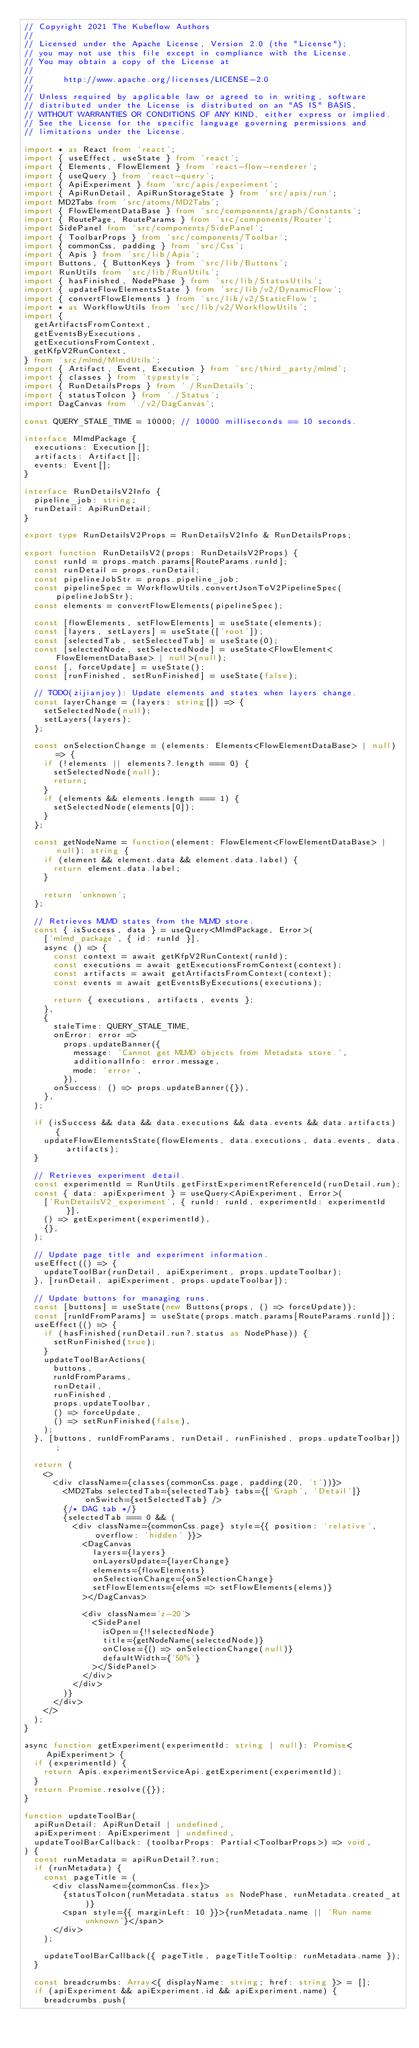Convert code to text. <code><loc_0><loc_0><loc_500><loc_500><_TypeScript_>// Copyright 2021 The Kubeflow Authors
//
// Licensed under the Apache License, Version 2.0 (the "License");
// you may not use this file except in compliance with the License.
// You may obtain a copy of the License at
//
//      http://www.apache.org/licenses/LICENSE-2.0
//
// Unless required by applicable law or agreed to in writing, software
// distributed under the License is distributed on an "AS IS" BASIS,
// WITHOUT WARRANTIES OR CONDITIONS OF ANY KIND, either express or implied.
// See the License for the specific language governing permissions and
// limitations under the License.

import * as React from 'react';
import { useEffect, useState } from 'react';
import { Elements, FlowElement } from 'react-flow-renderer';
import { useQuery } from 'react-query';
import { ApiExperiment } from 'src/apis/experiment';
import { ApiRunDetail, ApiRunStorageState } from 'src/apis/run';
import MD2Tabs from 'src/atoms/MD2Tabs';
import { FlowElementDataBase } from 'src/components/graph/Constants';
import { RoutePage, RouteParams } from 'src/components/Router';
import SidePanel from 'src/components/SidePanel';
import { ToolbarProps } from 'src/components/Toolbar';
import { commonCss, padding } from 'src/Css';
import { Apis } from 'src/lib/Apis';
import Buttons, { ButtonKeys } from 'src/lib/Buttons';
import RunUtils from 'src/lib/RunUtils';
import { hasFinished, NodePhase } from 'src/lib/StatusUtils';
import { updateFlowElementsState } from 'src/lib/v2/DynamicFlow';
import { convertFlowElements } from 'src/lib/v2/StaticFlow';
import * as WorkflowUtils from 'src/lib/v2/WorkflowUtils';
import {
  getArtifactsFromContext,
  getEventsByExecutions,
  getExecutionsFromContext,
  getKfpV2RunContext,
} from 'src/mlmd/MlmdUtils';
import { Artifact, Event, Execution } from 'src/third_party/mlmd';
import { classes } from 'typestyle';
import { RunDetailsProps } from './RunDetails';
import { statusToIcon } from './Status';
import DagCanvas from './v2/DagCanvas';

const QUERY_STALE_TIME = 10000; // 10000 milliseconds == 10 seconds.

interface MlmdPackage {
  executions: Execution[];
  artifacts: Artifact[];
  events: Event[];
}

interface RunDetailsV2Info {
  pipeline_job: string;
  runDetail: ApiRunDetail;
}

export type RunDetailsV2Props = RunDetailsV2Info & RunDetailsProps;

export function RunDetailsV2(props: RunDetailsV2Props) {
  const runId = props.match.params[RouteParams.runId];
  const runDetail = props.runDetail;
  const pipelineJobStr = props.pipeline_job;
  const pipelineSpec = WorkflowUtils.convertJsonToV2PipelineSpec(pipelineJobStr);
  const elements = convertFlowElements(pipelineSpec);

  const [flowElements, setFlowElements] = useState(elements);
  const [layers, setLayers] = useState(['root']);
  const [selectedTab, setSelectedTab] = useState(0);
  const [selectedNode, setSelectedNode] = useState<FlowElement<FlowElementDataBase> | null>(null);
  const [, forceUpdate] = useState();
  const [runFinished, setRunFinished] = useState(false);

  // TODO(zijianjoy): Update elements and states when layers change.
  const layerChange = (layers: string[]) => {
    setSelectedNode(null);
    setLayers(layers);
  };

  const onSelectionChange = (elements: Elements<FlowElementDataBase> | null) => {
    if (!elements || elements?.length === 0) {
      setSelectedNode(null);
      return;
    }
    if (elements && elements.length === 1) {
      setSelectedNode(elements[0]);
    }
  };

  const getNodeName = function(element: FlowElement<FlowElementDataBase> | null): string {
    if (element && element.data && element.data.label) {
      return element.data.label;
    }

    return 'unknown';
  };

  // Retrieves MLMD states from the MLMD store.
  const { isSuccess, data } = useQuery<MlmdPackage, Error>(
    ['mlmd_package', { id: runId }],
    async () => {
      const context = await getKfpV2RunContext(runId);
      const executions = await getExecutionsFromContext(context);
      const artifacts = await getArtifactsFromContext(context);
      const events = await getEventsByExecutions(executions);

      return { executions, artifacts, events };
    },
    {
      staleTime: QUERY_STALE_TIME,
      onError: error =>
        props.updateBanner({
          message: 'Cannot get MLMD objects from Metadata store.',
          additionalInfo: error.message,
          mode: 'error',
        }),
      onSuccess: () => props.updateBanner({}),
    },
  );

  if (isSuccess && data && data.executions && data.events && data.artifacts) {
    updateFlowElementsState(flowElements, data.executions, data.events, data.artifacts);
  }

  // Retrieves experiment detail.
  const experimentId = RunUtils.getFirstExperimentReferenceId(runDetail.run);
  const { data: apiExperiment } = useQuery<ApiExperiment, Error>(
    ['RunDetailsV2_experiment', { runId: runId, experimentId: experimentId }],
    () => getExperiment(experimentId),
    {},
  );

  // Update page title and experiment information.
  useEffect(() => {
    updateToolBar(runDetail, apiExperiment, props.updateToolbar);
  }, [runDetail, apiExperiment, props.updateToolbar]);

  // Update buttons for managing runs.
  const [buttons] = useState(new Buttons(props, () => forceUpdate));
  const [runIdFromParams] = useState(props.match.params[RouteParams.runId]);
  useEffect(() => {
    if (hasFinished(runDetail.run?.status as NodePhase)) {
      setRunFinished(true);
    }
    updateToolBarActions(
      buttons,
      runIdFromParams,
      runDetail,
      runFinished,
      props.updateToolbar,
      () => forceUpdate,
      () => setRunFinished(false),
    );
  }, [buttons, runIdFromParams, runDetail, runFinished, props.updateToolbar]);

  return (
    <>
      <div className={classes(commonCss.page, padding(20, 't'))}>
        <MD2Tabs selectedTab={selectedTab} tabs={['Graph', 'Detail']} onSwitch={setSelectedTab} />
        {/* DAG tab */}
        {selectedTab === 0 && (
          <div className={commonCss.page} style={{ position: 'relative', overflow: 'hidden' }}>
            <DagCanvas
              layers={layers}
              onLayersUpdate={layerChange}
              elements={flowElements}
              onSelectionChange={onSelectionChange}
              setFlowElements={elems => setFlowElements(elems)}
            ></DagCanvas>

            <div className='z-20'>
              <SidePanel
                isOpen={!!selectedNode}
                title={getNodeName(selectedNode)}
                onClose={() => onSelectionChange(null)}
                defaultWidth={'50%'}
              ></SidePanel>
            </div>
          </div>
        )}
      </div>
    </>
  );
}

async function getExperiment(experimentId: string | null): Promise<ApiExperiment> {
  if (experimentId) {
    return Apis.experimentServiceApi.getExperiment(experimentId);
  }
  return Promise.resolve({});
}

function updateToolBar(
  apiRunDetail: ApiRunDetail | undefined,
  apiExperiment: ApiExperiment | undefined,
  updateToolBarCallback: (toolbarProps: Partial<ToolbarProps>) => void,
) {
  const runMetadata = apiRunDetail?.run;
  if (runMetadata) {
    const pageTitle = (
      <div className={commonCss.flex}>
        {statusToIcon(runMetadata.status as NodePhase, runMetadata.created_at)}
        <span style={{ marginLeft: 10 }}>{runMetadata.name || 'Run name unknown'}</span>
      </div>
    );

    updateToolBarCallback({ pageTitle, pageTitleTooltip: runMetadata.name });
  }

  const breadcrumbs: Array<{ displayName: string; href: string }> = [];
  if (apiExperiment && apiExperiment.id && apiExperiment.name) {
    breadcrumbs.push(</code> 